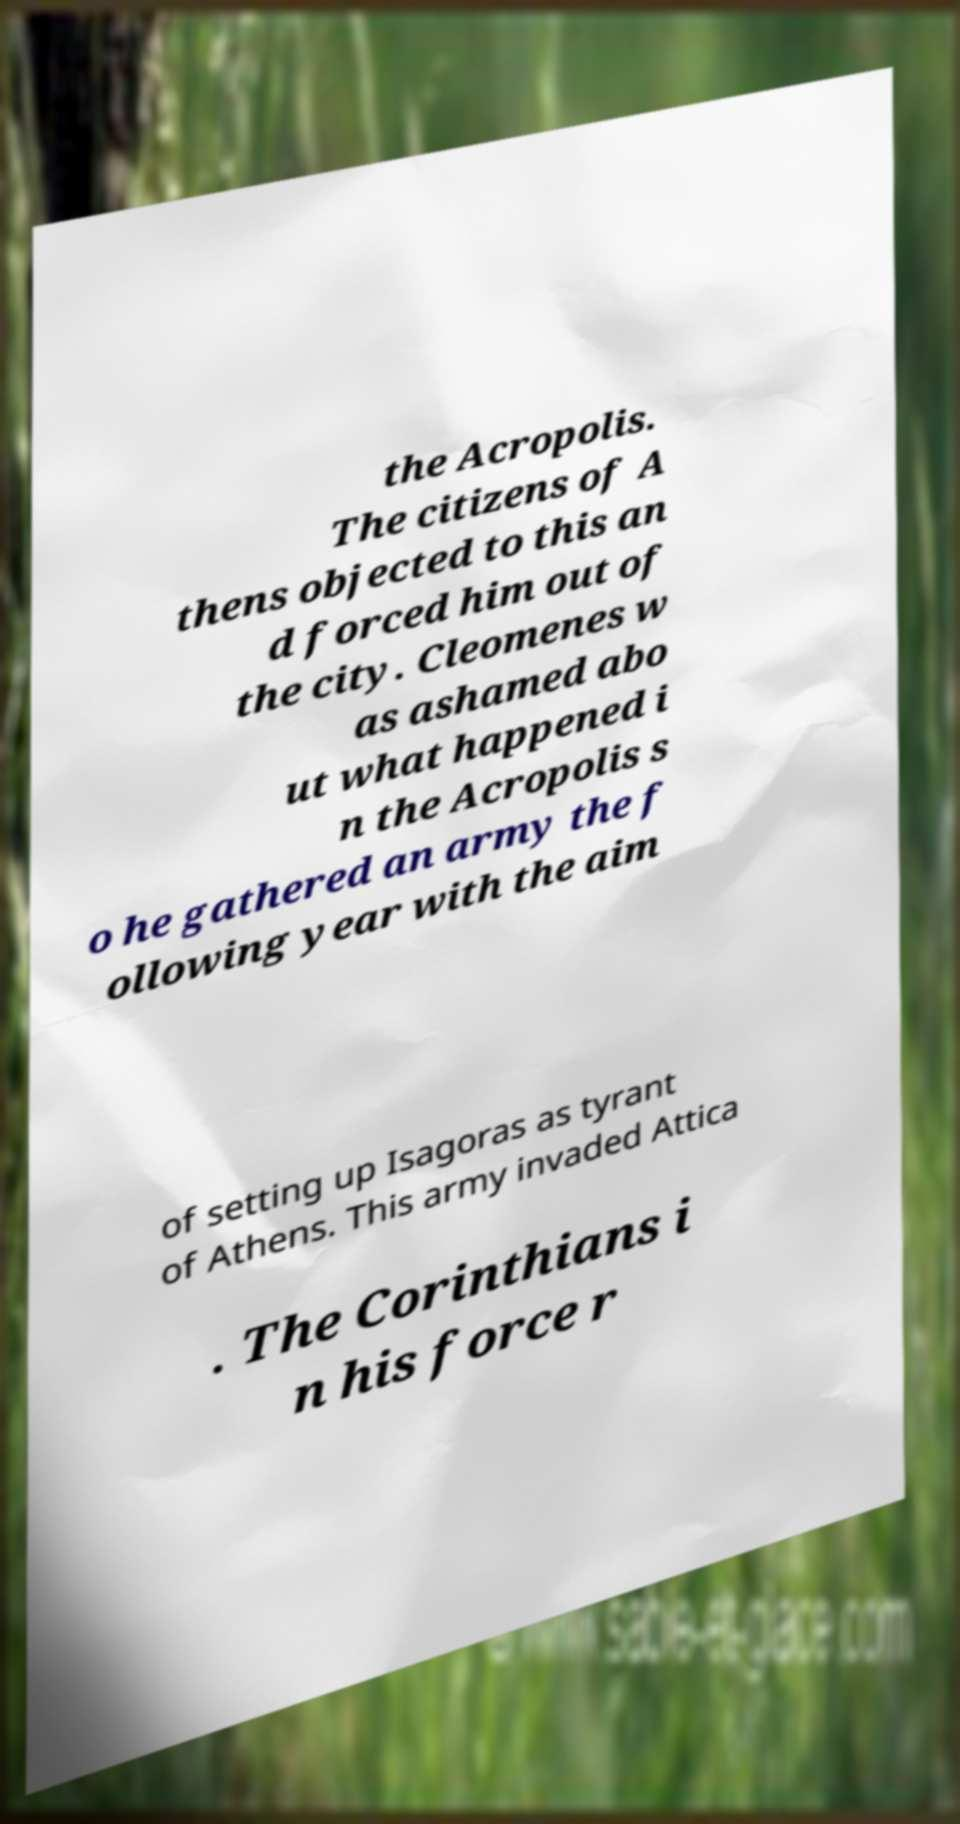Can you accurately transcribe the text from the provided image for me? the Acropolis. The citizens of A thens objected to this an d forced him out of the city. Cleomenes w as ashamed abo ut what happened i n the Acropolis s o he gathered an army the f ollowing year with the aim of setting up Isagoras as tyrant of Athens. This army invaded Attica . The Corinthians i n his force r 